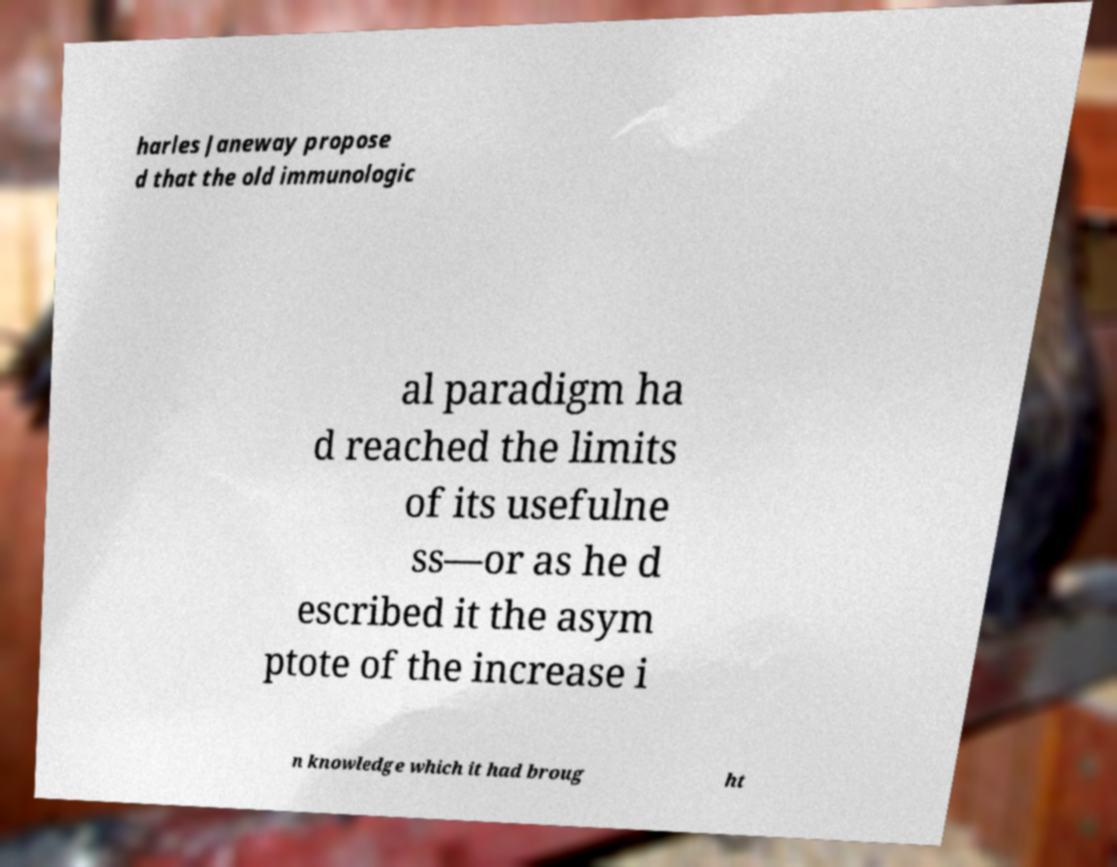Could you extract and type out the text from this image? harles Janeway propose d that the old immunologic al paradigm ha d reached the limits of its usefulne ss—or as he d escribed it the asym ptote of the increase i n knowledge which it had broug ht 